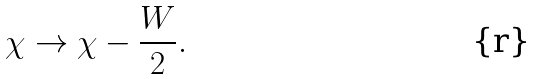<formula> <loc_0><loc_0><loc_500><loc_500>\chi \to \chi - \frac { W } { 2 } .</formula> 